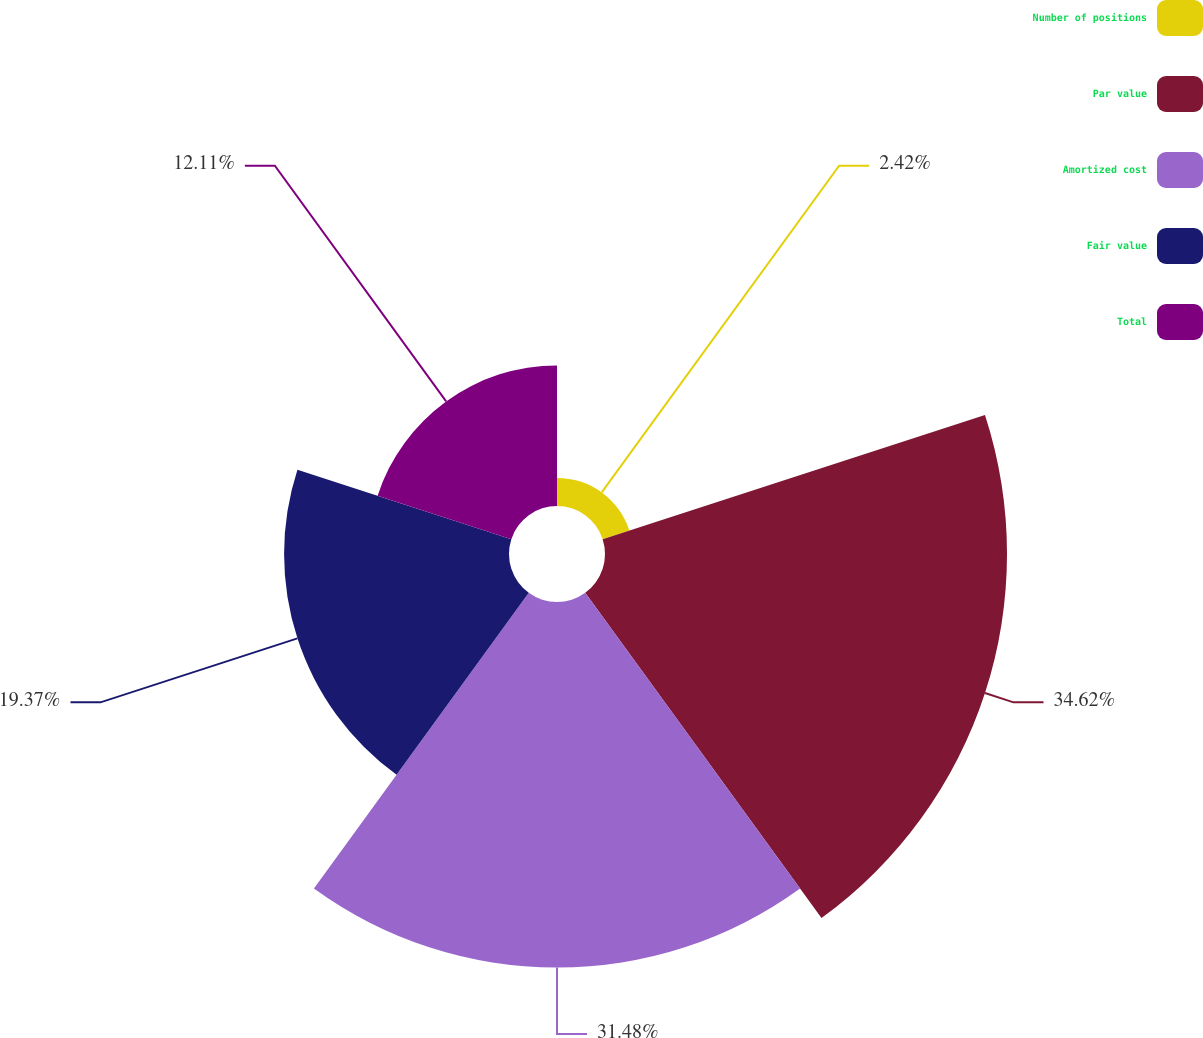Convert chart. <chart><loc_0><loc_0><loc_500><loc_500><pie_chart><fcel>Number of positions<fcel>Par value<fcel>Amortized cost<fcel>Fair value<fcel>Total<nl><fcel>2.42%<fcel>34.62%<fcel>31.48%<fcel>19.37%<fcel>12.11%<nl></chart> 